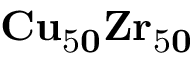<formula> <loc_0><loc_0><loc_500><loc_500>C u _ { \mathrm { 5 } 0 } Z r _ { \mathrm { 5 } 0 }</formula> 